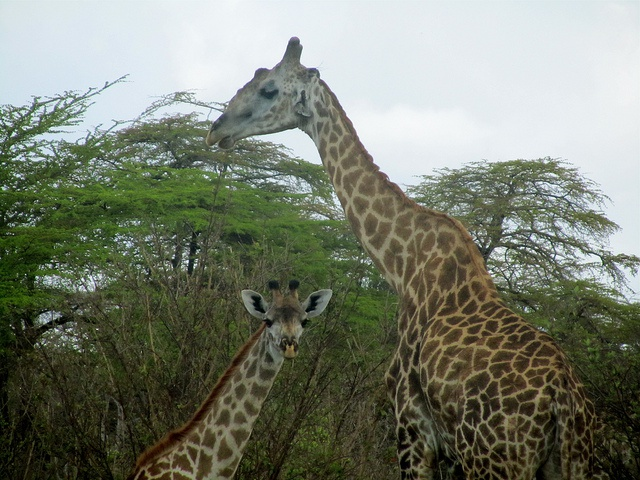Describe the objects in this image and their specific colors. I can see giraffe in lightgray, gray, and black tones and giraffe in lightgray, gray, black, and darkgreen tones in this image. 